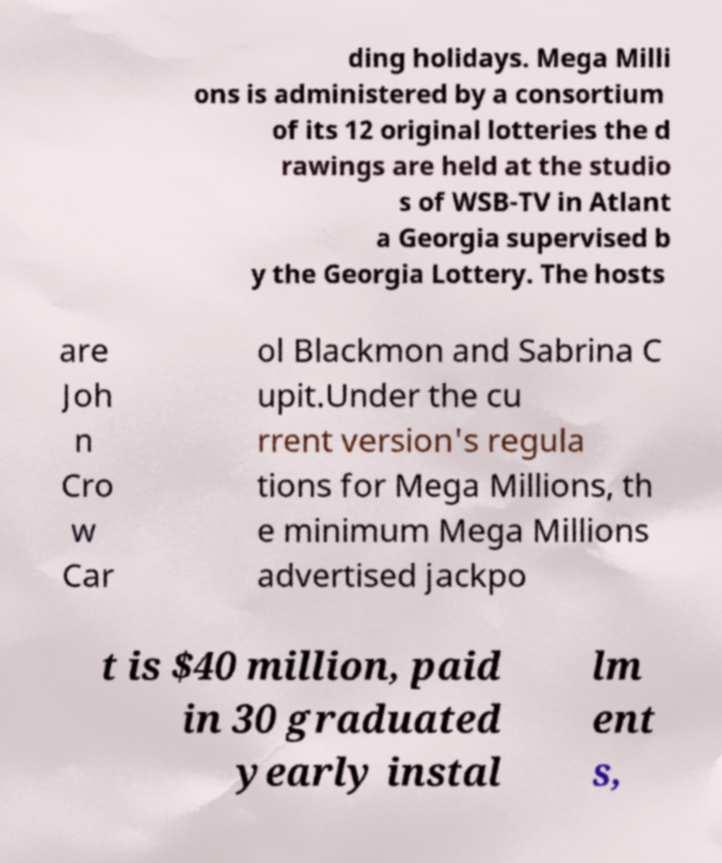Can you read and provide the text displayed in the image?This photo seems to have some interesting text. Can you extract and type it out for me? ding holidays. Mega Milli ons is administered by a consortium of its 12 original lotteries the d rawings are held at the studio s of WSB-TV in Atlant a Georgia supervised b y the Georgia Lottery. The hosts are Joh n Cro w Car ol Blackmon and Sabrina C upit.Under the cu rrent version's regula tions for Mega Millions, th e minimum Mega Millions advertised jackpo t is $40 million, paid in 30 graduated yearly instal lm ent s, 